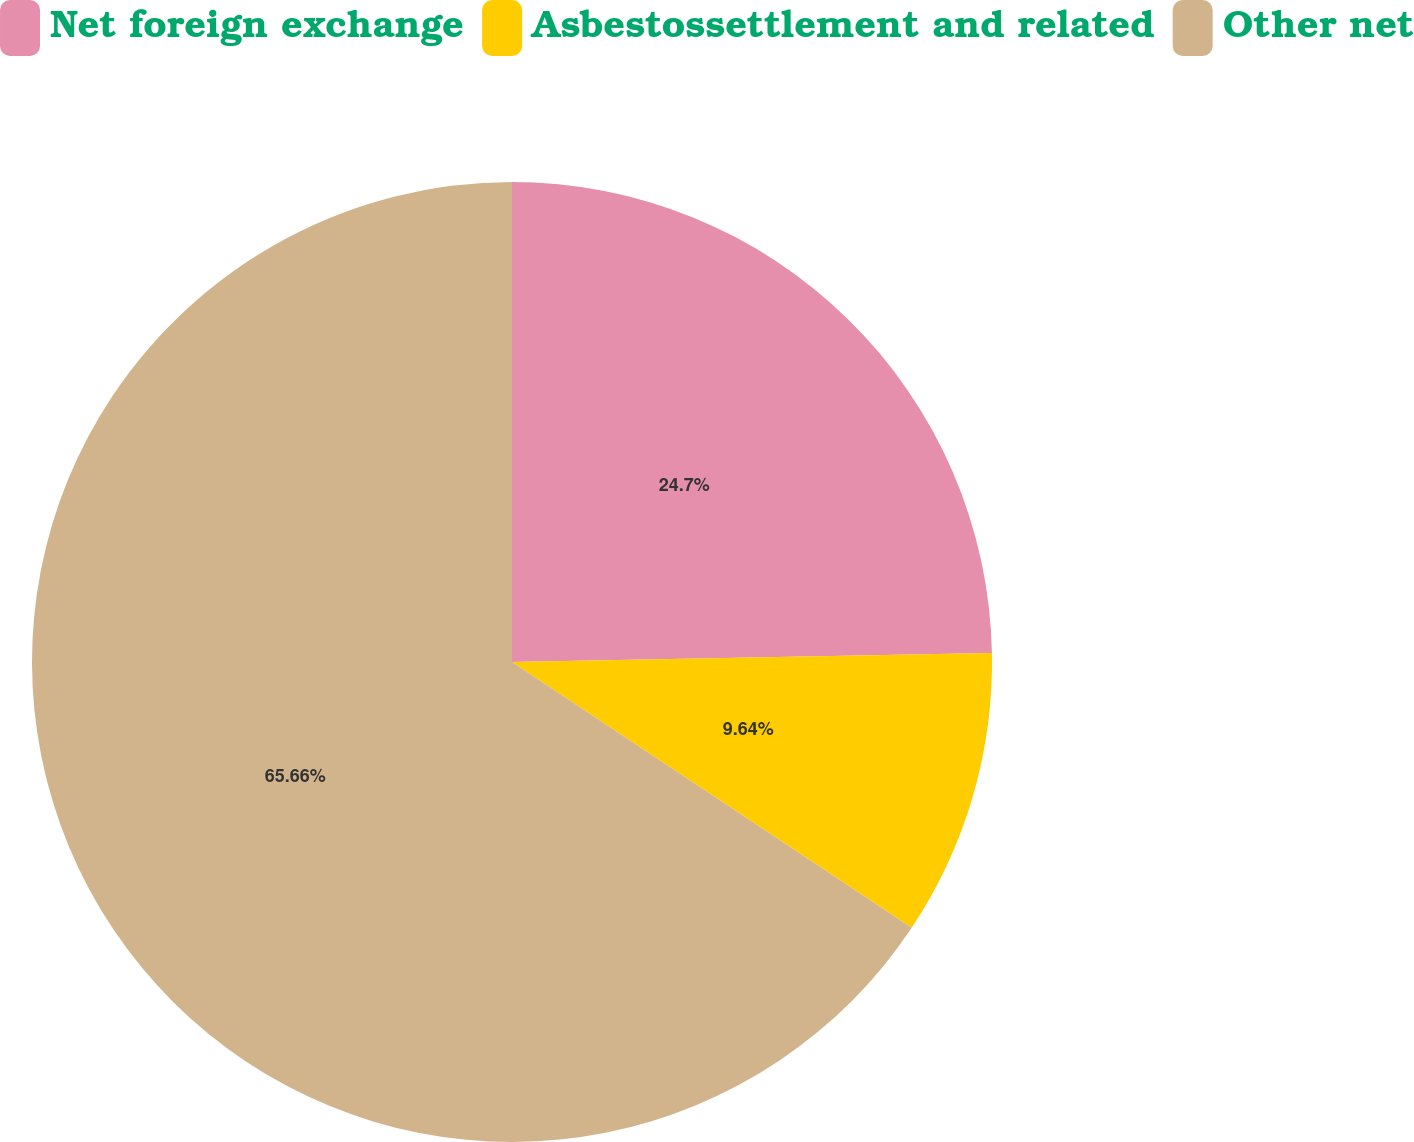Convert chart. <chart><loc_0><loc_0><loc_500><loc_500><pie_chart><fcel>Net foreign exchange<fcel>Asbestossettlement and related<fcel>Other net<nl><fcel>24.7%<fcel>9.64%<fcel>65.66%<nl></chart> 